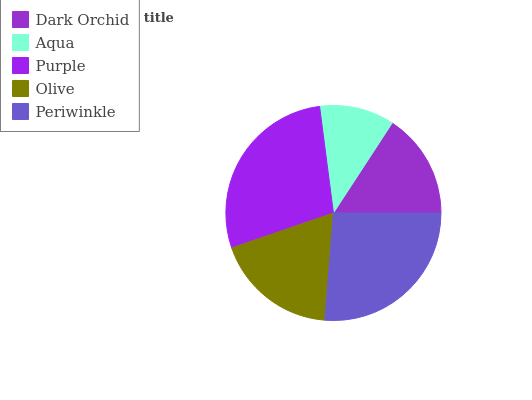Is Aqua the minimum?
Answer yes or no. Yes. Is Purple the maximum?
Answer yes or no. Yes. Is Purple the minimum?
Answer yes or no. No. Is Aqua the maximum?
Answer yes or no. No. Is Purple greater than Aqua?
Answer yes or no. Yes. Is Aqua less than Purple?
Answer yes or no. Yes. Is Aqua greater than Purple?
Answer yes or no. No. Is Purple less than Aqua?
Answer yes or no. No. Is Olive the high median?
Answer yes or no. Yes. Is Olive the low median?
Answer yes or no. Yes. Is Periwinkle the high median?
Answer yes or no. No. Is Aqua the low median?
Answer yes or no. No. 